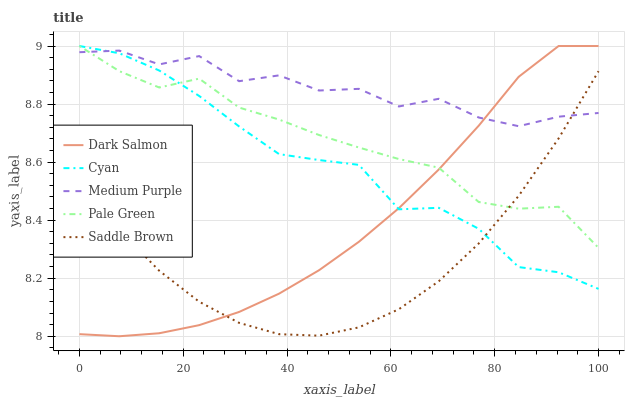Does Saddle Brown have the minimum area under the curve?
Answer yes or no. Yes. Does Medium Purple have the maximum area under the curve?
Answer yes or no. Yes. Does Cyan have the minimum area under the curve?
Answer yes or no. No. Does Cyan have the maximum area under the curve?
Answer yes or no. No. Is Dark Salmon the smoothest?
Answer yes or no. Yes. Is Medium Purple the roughest?
Answer yes or no. Yes. Is Cyan the smoothest?
Answer yes or no. No. Is Cyan the roughest?
Answer yes or no. No. Does Dark Salmon have the lowest value?
Answer yes or no. Yes. Does Cyan have the lowest value?
Answer yes or no. No. Does Dark Salmon have the highest value?
Answer yes or no. Yes. Does Saddle Brown have the highest value?
Answer yes or no. No. Does Pale Green intersect Saddle Brown?
Answer yes or no. Yes. Is Pale Green less than Saddle Brown?
Answer yes or no. No. Is Pale Green greater than Saddle Brown?
Answer yes or no. No. 